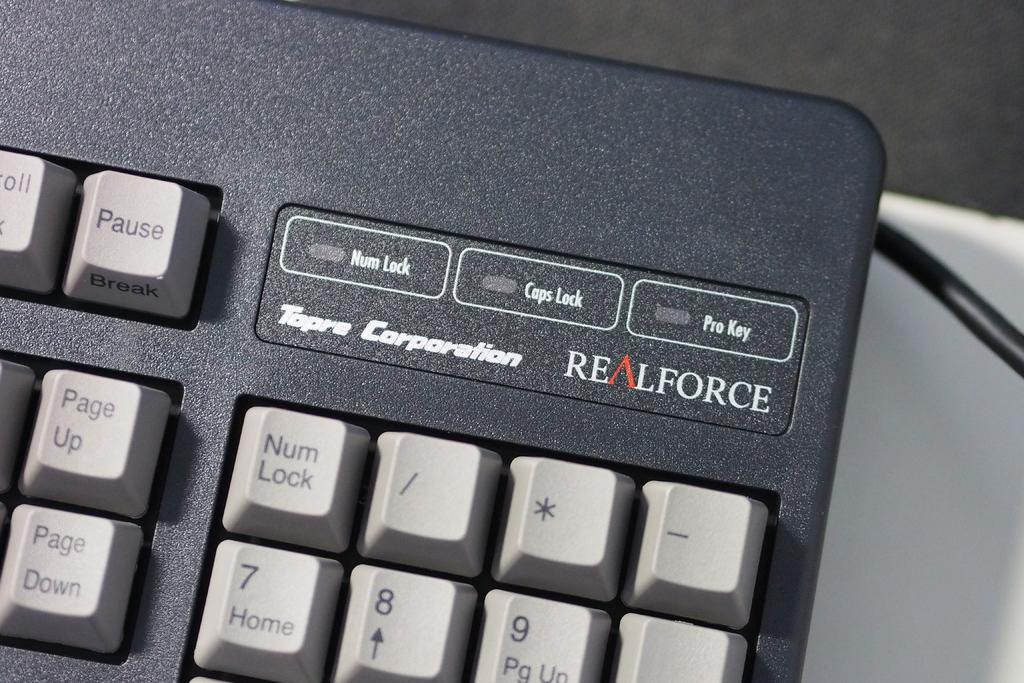<image>
Render a clear and concise summary of the photo. A computer keyboard that is black and grey made by the Tapre Corporation. 